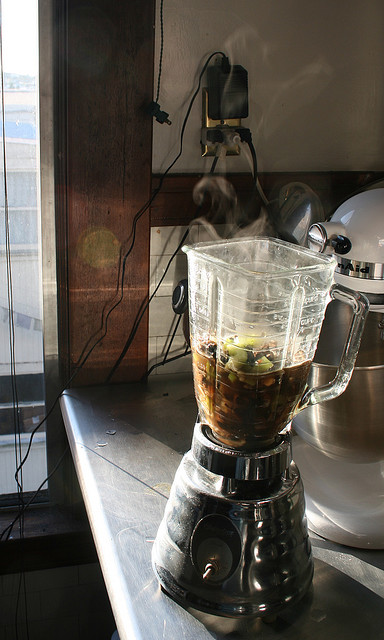<image>Is the window behind the drink locked or unlocked? It is impossible to tell if the window behind the drink is locked or unlocked. Is the window behind the drink locked or unlocked? I don't know if the window behind the drink is locked or unlocked. It can be seen both locked and impossible to tell. 